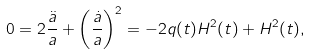<formula> <loc_0><loc_0><loc_500><loc_500>0 = 2 \frac { \ddot { a } } { a } + \left ( \frac { \dot { a } } { a } \right ) ^ { 2 } = - 2 q ( t ) H ^ { 2 } ( t ) + H ^ { 2 } ( t ) ,</formula> 